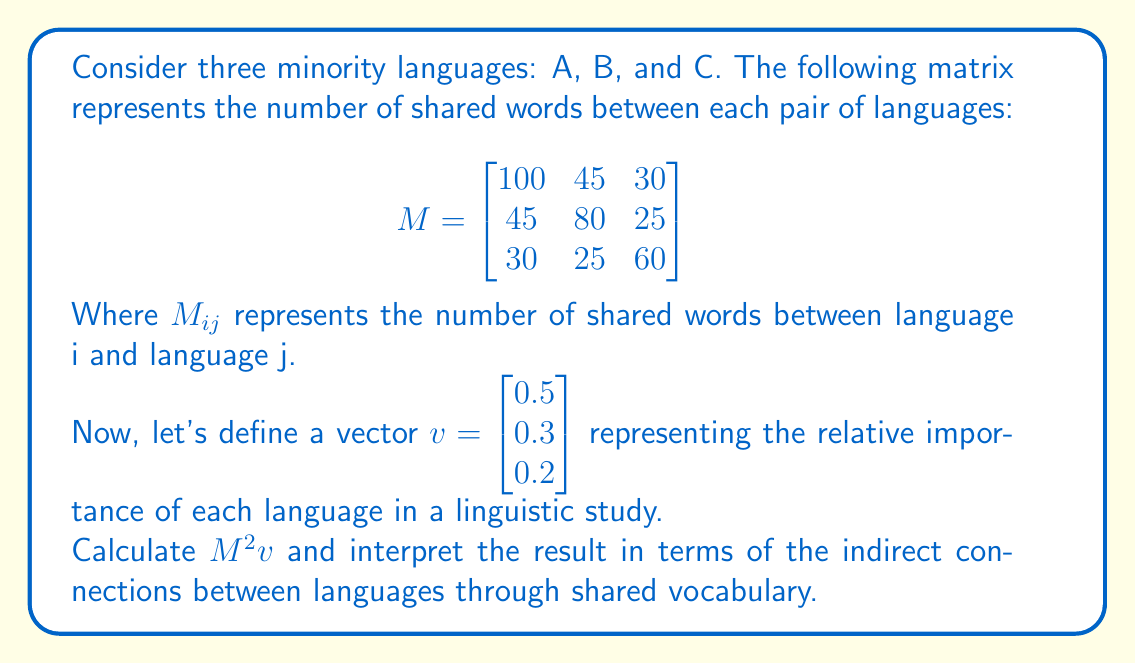Solve this math problem. To solve this problem, we need to follow these steps:

1) First, calculate $M^2$:

$$ M^2 = M \times M = \begin{bmatrix}
100 & 45 & 30 \\
45 & 80 & 25 \\
30 & 25 & 60
\end{bmatrix} \times \begin{bmatrix}
100 & 45 & 30 \\
45 & 80 & 25 \\
30 & 25 & 60
\end{bmatrix} $$

$$ M^2 = \begin{bmatrix}
13225 & 9675 & 6450 \\
9675 & 8650 & 4875 \\
6450 & 4875 & 4900
\end{bmatrix} $$

2) Now, calculate $M^2v$:

$$ M^2v = \begin{bmatrix}
13225 & 9675 & 6450 \\
9675 & 8650 & 4875 \\
6450 & 4875 & 4900
\end{bmatrix} \times \begin{bmatrix}
0.5 \\
0.3 \\
0.2
\end{bmatrix} $$

$$ M^2v = \begin{bmatrix}
13225(0.5) + 9675(0.3) + 6450(0.2) \\
9675(0.5) + 8650(0.3) + 4875(0.2) \\
6450(0.5) + 4875(0.3) + 4900(0.2)
\end{bmatrix} $$

$$ M^2v = \begin{bmatrix}
10537.5 \\
8197.5 \\
5557.5
\end{bmatrix} $$

3) Interpretation:
The resulting vector represents the indirect connections between languages through shared vocabulary, weighted by their importance. 

- The first element (10537.5) represents the strength of indirect connections for language A.
- The second element (8197.5) represents the strength of indirect connections for language B.
- The third element (5557.5) represents the strength of indirect connections for language C.

These values take into account not only direct shared vocabulary but also words shared through intermediate languages, weighted by the importance of each language in the study.
Answer: $$ M^2v = \begin{bmatrix}
10537.5 \\
8197.5 \\
5557.5
\end{bmatrix} $$

This result indicates that language A has the strongest indirect connections, followed by language B, and then language C, when considering both direct and indirect shared vocabulary and the relative importance of each language. 